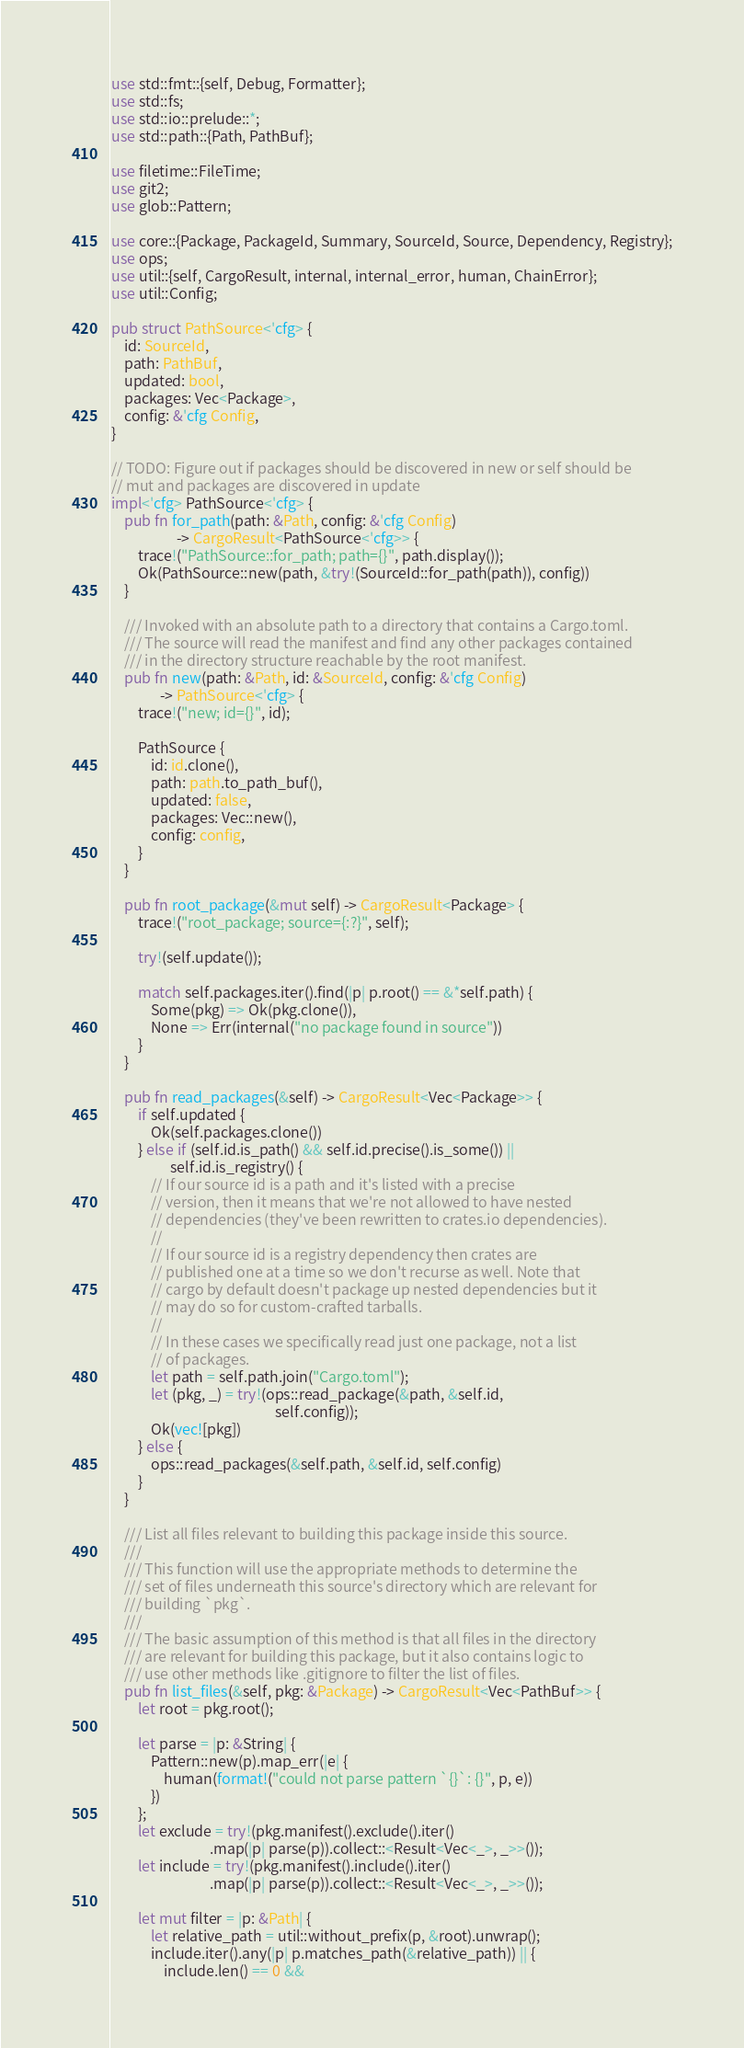Convert code to text. <code><loc_0><loc_0><loc_500><loc_500><_Rust_>use std::fmt::{self, Debug, Formatter};
use std::fs;
use std::io::prelude::*;
use std::path::{Path, PathBuf};

use filetime::FileTime;
use git2;
use glob::Pattern;

use core::{Package, PackageId, Summary, SourceId, Source, Dependency, Registry};
use ops;
use util::{self, CargoResult, internal, internal_error, human, ChainError};
use util::Config;

pub struct PathSource<'cfg> {
    id: SourceId,
    path: PathBuf,
    updated: bool,
    packages: Vec<Package>,
    config: &'cfg Config,
}

// TODO: Figure out if packages should be discovered in new or self should be
// mut and packages are discovered in update
impl<'cfg> PathSource<'cfg> {
    pub fn for_path(path: &Path, config: &'cfg Config)
                    -> CargoResult<PathSource<'cfg>> {
        trace!("PathSource::for_path; path={}", path.display());
        Ok(PathSource::new(path, &try!(SourceId::for_path(path)), config))
    }

    /// Invoked with an absolute path to a directory that contains a Cargo.toml.
    /// The source will read the manifest and find any other packages contained
    /// in the directory structure reachable by the root manifest.
    pub fn new(path: &Path, id: &SourceId, config: &'cfg Config)
               -> PathSource<'cfg> {
        trace!("new; id={}", id);

        PathSource {
            id: id.clone(),
            path: path.to_path_buf(),
            updated: false,
            packages: Vec::new(),
            config: config,
        }
    }

    pub fn root_package(&mut self) -> CargoResult<Package> {
        trace!("root_package; source={:?}", self);

        try!(self.update());

        match self.packages.iter().find(|p| p.root() == &*self.path) {
            Some(pkg) => Ok(pkg.clone()),
            None => Err(internal("no package found in source"))
        }
    }

    pub fn read_packages(&self) -> CargoResult<Vec<Package>> {
        if self.updated {
            Ok(self.packages.clone())
        } else if (self.id.is_path() && self.id.precise().is_some()) ||
                  self.id.is_registry() {
            // If our source id is a path and it's listed with a precise
            // version, then it means that we're not allowed to have nested
            // dependencies (they've been rewritten to crates.io dependencies).
            //
            // If our source id is a registry dependency then crates are
            // published one at a time so we don't recurse as well. Note that
            // cargo by default doesn't package up nested dependencies but it
            // may do so for custom-crafted tarballs.
            //
            // In these cases we specifically read just one package, not a list
            // of packages.
            let path = self.path.join("Cargo.toml");
            let (pkg, _) = try!(ops::read_package(&path, &self.id,
                                                  self.config));
            Ok(vec![pkg])
        } else {
            ops::read_packages(&self.path, &self.id, self.config)
        }
    }

    /// List all files relevant to building this package inside this source.
    ///
    /// This function will use the appropriate methods to determine the
    /// set of files underneath this source's directory which are relevant for
    /// building `pkg`.
    ///
    /// The basic assumption of this method is that all files in the directory
    /// are relevant for building this package, but it also contains logic to
    /// use other methods like .gitignore to filter the list of files.
    pub fn list_files(&self, pkg: &Package) -> CargoResult<Vec<PathBuf>> {
        let root = pkg.root();

        let parse = |p: &String| {
            Pattern::new(p).map_err(|e| {
                human(format!("could not parse pattern `{}`: {}", p, e))
            })
        };
        let exclude = try!(pkg.manifest().exclude().iter()
                              .map(|p| parse(p)).collect::<Result<Vec<_>, _>>());
        let include = try!(pkg.manifest().include().iter()
                              .map(|p| parse(p)).collect::<Result<Vec<_>, _>>());

        let mut filter = |p: &Path| {
            let relative_path = util::without_prefix(p, &root).unwrap();
            include.iter().any(|p| p.matches_path(&relative_path)) || {
                include.len() == 0 &&</code> 